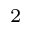Convert formula to latex. <formula><loc_0><loc_0><loc_500><loc_500>_ { 2 }</formula> 